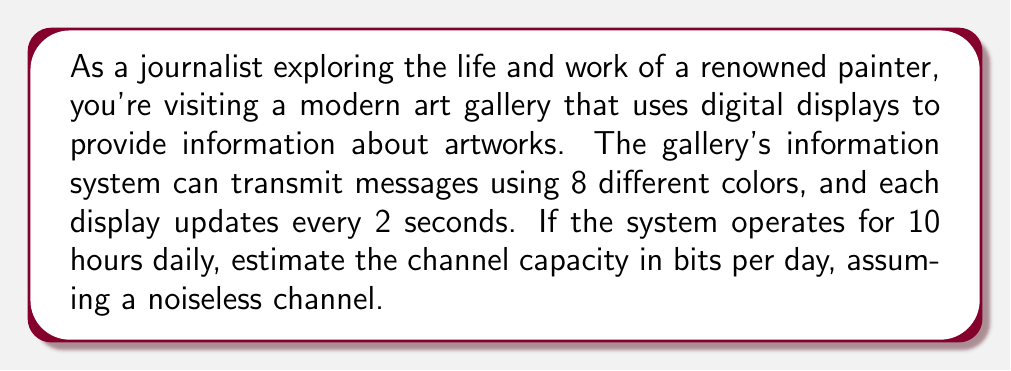Can you answer this question? To solve this problem, we'll use the concepts of information theory to calculate the channel capacity. Let's break it down step-by-step:

1. Identify the number of possible symbols:
   The system uses 8 different colors, so we have 8 possible symbols.

2. Calculate the information content per symbol:
   The information content per symbol is given by $\log_2(n)$, where $n$ is the number of possible symbols.
   Information content = $\log_2(8) = 3$ bits per symbol

3. Determine the symbol rate:
   The display updates every 2 seconds, so the symbol rate is:
   Symbol rate = $\frac{1}{2}$ symbols per second

4. Calculate the channel capacity per second:
   Channel capacity = Information content per symbol × Symbol rate
   $$C = 3 \times \frac{1}{2} = 1.5$$ bits per second

5. Convert to bits per day:
   The system operates for 10 hours daily.
   Seconds per day = 10 hours × 3600 seconds/hour = 36,000 seconds
   
   Channel capacity per day = Channel capacity per second × Seconds per day
   $$C_{day} = 1.5 \times 36,000 = 54,000$$ bits per day

Therefore, the estimated channel capacity of the art gallery's information display system is 54,000 bits per day.
Answer: 54,000 bits per day 